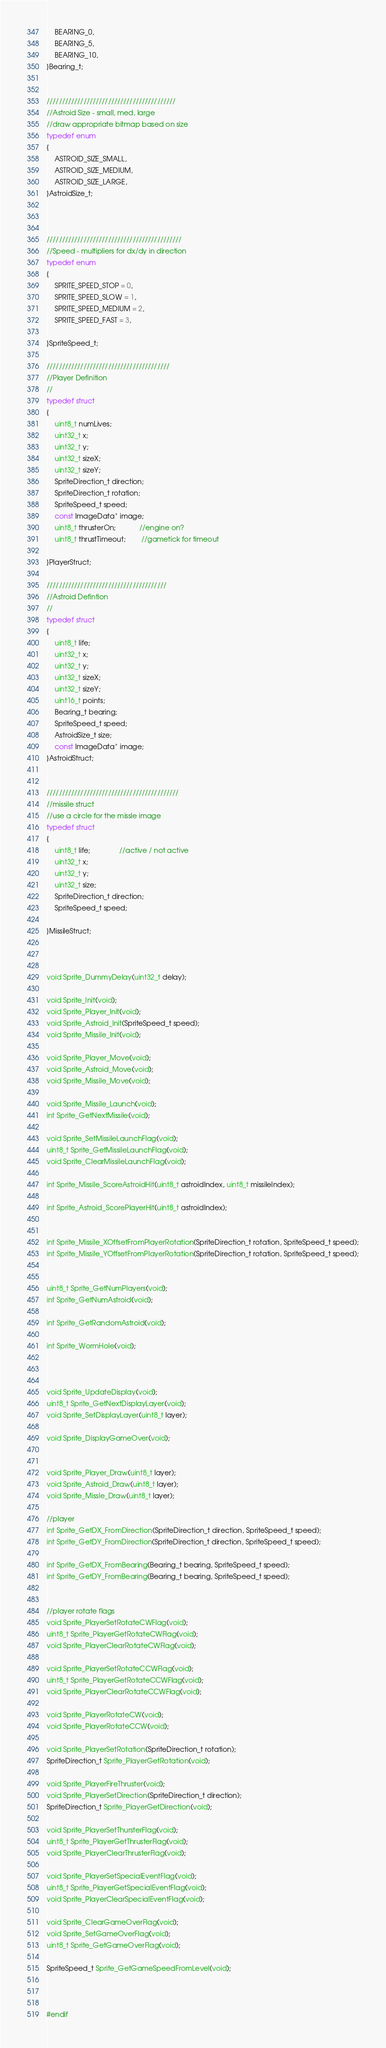<code> <loc_0><loc_0><loc_500><loc_500><_C_>	BEARING_0,
	BEARING_5,
	BEARING_10,
}Bearing_t;


//////////////////////////////////////////
//Astroid Size - small, med, large
//draw appropriate bitmap based on size
typedef enum
{
	ASTROID_SIZE_SMALL,
	ASTROID_SIZE_MEDIUM,
	ASTROID_SIZE_LARGE,
}AstroidSize_t;



////////////////////////////////////////////
//Speed - multipliers for dx/dy in direction
typedef enum
{
	SPRITE_SPEED_STOP = 0,
	SPRITE_SPEED_SLOW = 1,
	SPRITE_SPEED_MEDIUM = 2,
	SPRITE_SPEED_FAST = 3,

}SpriteSpeed_t;

////////////////////////////////////////
//Player Definition
//
typedef struct
{
	uint8_t numLives;
	uint32_t x;
	uint32_t y;
	uint32_t sizeX;
	uint32_t sizeY;
	SpriteDirection_t direction;
	SpriteDirection_t rotation;
	SpriteSpeed_t speed;
	const ImageData* image;
	uint8_t thrusterOn;			//engine on?
	uint8_t thrustTimeout;		//gametick for timeout

}PlayerStruct;

///////////////////////////////////////
//Astroid Defintion
//
typedef struct
{
	uint8_t life;
	uint32_t x;
	uint32_t y;
	uint32_t sizeX;
	uint32_t sizeY;
	uint16_t points;
	Bearing_t bearing;
    SpriteSpeed_t speed;
    AstroidSize_t size;
	const ImageData* image;
}AstroidStruct;


///////////////////////////////////////////
//missile struct
//use a circle for the missle image
typedef struct
{
	uint8_t life;               //active / not active
	uint32_t x;
	uint32_t y;
	uint32_t size;
    SpriteDirection_t direction;
    SpriteSpeed_t speed;

}MissileStruct;



void Sprite_DummyDelay(uint32_t delay);

void Sprite_Init(void);
void Sprite_Player_Init(void);
void Sprite_Astroid_Init(SpriteSpeed_t speed);
void Sprite_Missile_Init(void);

void Sprite_Player_Move(void);
void Sprite_Astroid_Move(void);
void Sprite_Missile_Move(void);

void Sprite_Missile_Launch(void);
int Sprite_GetNextMissile(void);

void Sprite_SetMissileLaunchFlag(void);
uint8_t Sprite_GetMissileLaunchFlag(void);
void Sprite_ClearMissileLaunchFlag(void);

int Sprite_Missile_ScoreAstroidHit(uint8_t astroidIndex, uint8_t missileIndex);

int Sprite_Astroid_ScorePlayerHit(uint8_t astroidIndex);


int Sprite_Missile_XOffsetFromPlayerRotation(SpriteDirection_t rotation, SpriteSpeed_t speed);
int Sprite_Missile_YOffsetFromPlayerRotation(SpriteDirection_t rotation, SpriteSpeed_t speed);


uint8_t Sprite_GetNumPlayers(void);
int Sprite_GetNumAstroid(void);

int Sprite_GetRandomAstroid(void);

int Sprite_WormHole(void);



void Sprite_UpdateDisplay(void);
uint8_t Sprite_GetNextDisplayLayer(void);
void Sprite_SetDisplayLayer(uint8_t layer);

void Sprite_DisplayGameOver(void);


void Sprite_Player_Draw(uint8_t layer);
void Sprite_Astroid_Draw(uint8_t layer);
void Sprite_Missle_Draw(uint8_t layer);

//player
int Sprite_GetDX_FromDirection(SpriteDirection_t direction, SpriteSpeed_t speed);
int Sprite_GetDY_FromDirection(SpriteDirection_t direction, SpriteSpeed_t speed);

int Sprite_GetDX_FromBearing(Bearing_t bearing, SpriteSpeed_t speed);
int Sprite_GetDY_FromBearing(Bearing_t bearing, SpriteSpeed_t speed);


//player rotate flags
void Sprite_PlayerSetRotateCWFlag(void);
uint8_t Sprite_PlayerGetRotateCWFlag(void);
void Sprite_PlayerClearRotateCWFlag(void);

void Sprite_PlayerSetRotateCCWFlag(void);
uint8_t Sprite_PlayerGetRotateCCWFlag(void);
void Sprite_PlayerClearRotateCCWFlag(void);

void Sprite_PlayerRotateCW(void);
void Sprite_PlayerRotateCCW(void);

void Sprite_PlayerSetRotation(SpriteDirection_t rotation);
SpriteDirection_t Sprite_PlayerGetRotation(void);

void Sprite_PlayerFireThruster(void);
void Sprite_PlayerSetDirection(SpriteDirection_t direction);
SpriteDirection_t Sprite_PlayerGetDirection(void);

void Sprite_PlayerSetThursterFlag(void);
uint8_t Sprite_PlayerGetThrusterFlag(void);
void Sprite_PlayerClearThrusterFlag(void);

void Sprite_PlayerSetSpecialEventFlag(void);
uint8_t Sprite_PlayerGetSpecialEventFlag(void);
void Sprite_PlayerClearSpecialEventFlag(void);

void Sprite_ClearGameOverFlag(void);
void Sprite_SetGameOverFlag(void);
uint8_t Sprite_GetGameOverFlag(void);

SpriteSpeed_t Sprite_GetGameSpeedFromLevel(void);



#endif
</code> 